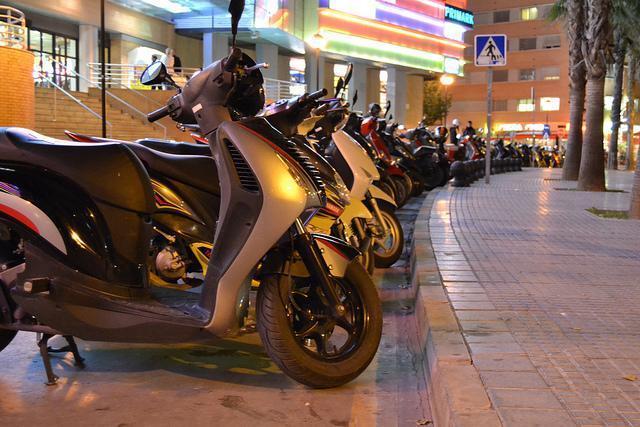How many motorcycles are in the photo?
Give a very brief answer. 3. 